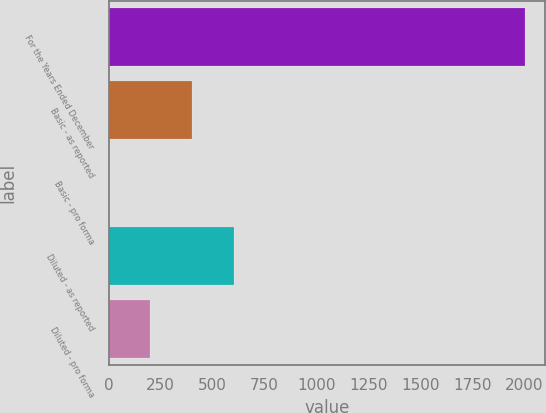Convert chart to OTSL. <chart><loc_0><loc_0><loc_500><loc_500><bar_chart><fcel>For the Years Ended December<fcel>Basic - as reported<fcel>Basic - pro forma<fcel>Diluted - as reported<fcel>Diluted - pro forma<nl><fcel>2000<fcel>400.69<fcel>0.87<fcel>600.6<fcel>200.78<nl></chart> 